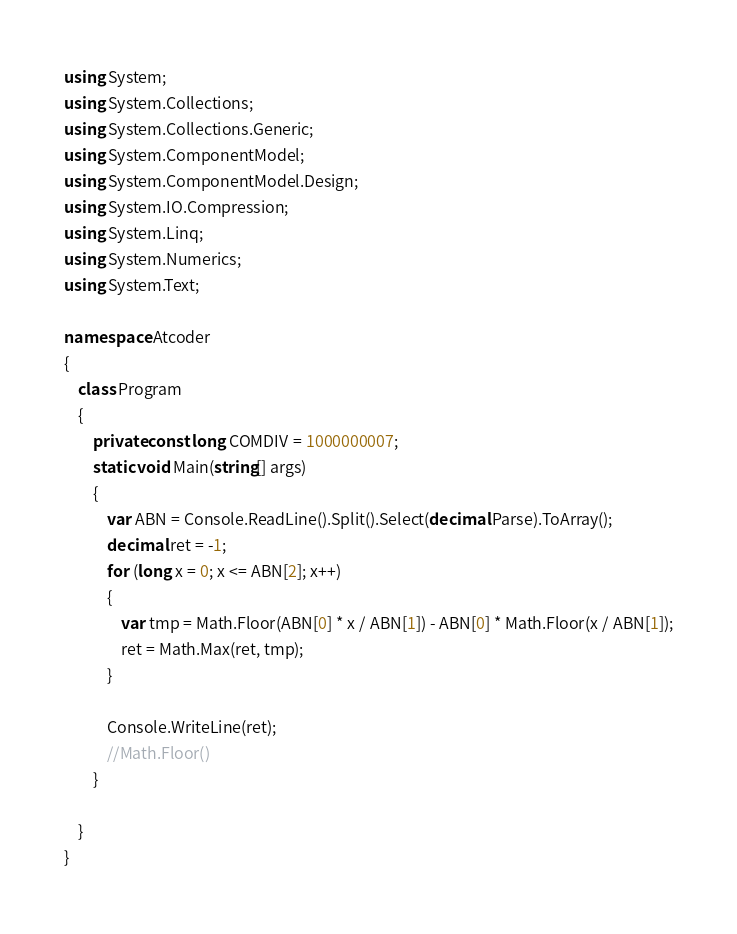<code> <loc_0><loc_0><loc_500><loc_500><_C#_>using System;
using System.Collections;
using System.Collections.Generic;
using System.ComponentModel;
using System.ComponentModel.Design;
using System.IO.Compression;
using System.Linq;
using System.Numerics;
using System.Text;

namespace Atcoder
{
    class Program
    {
        private const long COMDIV = 1000000007;
        static void Main(string[] args)
        {
            var ABN = Console.ReadLine().Split().Select(decimal.Parse).ToArray();
            decimal ret = -1;
            for (long x = 0; x <= ABN[2]; x++)
            {
                var tmp = Math.Floor(ABN[0] * x / ABN[1]) - ABN[0] * Math.Floor(x / ABN[1]);
                ret = Math.Max(ret, tmp);
            }

            Console.WriteLine(ret);
            //Math.Floor()
        }
        
    }
}</code> 